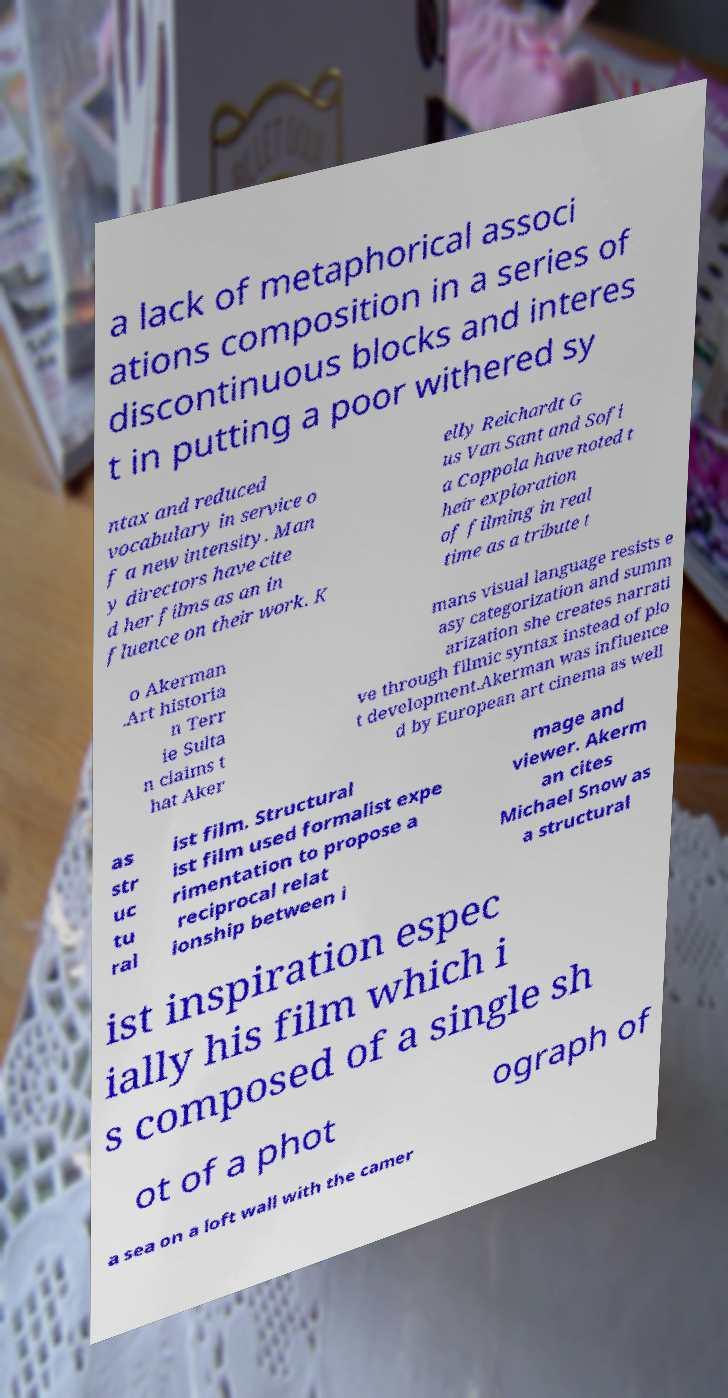Please identify and transcribe the text found in this image. a lack of metaphorical associ ations composition in a series of discontinuous blocks and interes t in putting a poor withered sy ntax and reduced vocabulary in service o f a new intensity. Man y directors have cite d her films as an in fluence on their work. K elly Reichardt G us Van Sant and Sofi a Coppola have noted t heir exploration of filming in real time as a tribute t o Akerman .Art historia n Terr ie Sulta n claims t hat Aker mans visual language resists e asy categorization and summ arization she creates narrati ve through filmic syntax instead of plo t development.Akerman was influence d by European art cinema as well as str uc tu ral ist film. Structural ist film used formalist expe rimentation to propose a reciprocal relat ionship between i mage and viewer. Akerm an cites Michael Snow as a structural ist inspiration espec ially his film which i s composed of a single sh ot of a phot ograph of a sea on a loft wall with the camer 